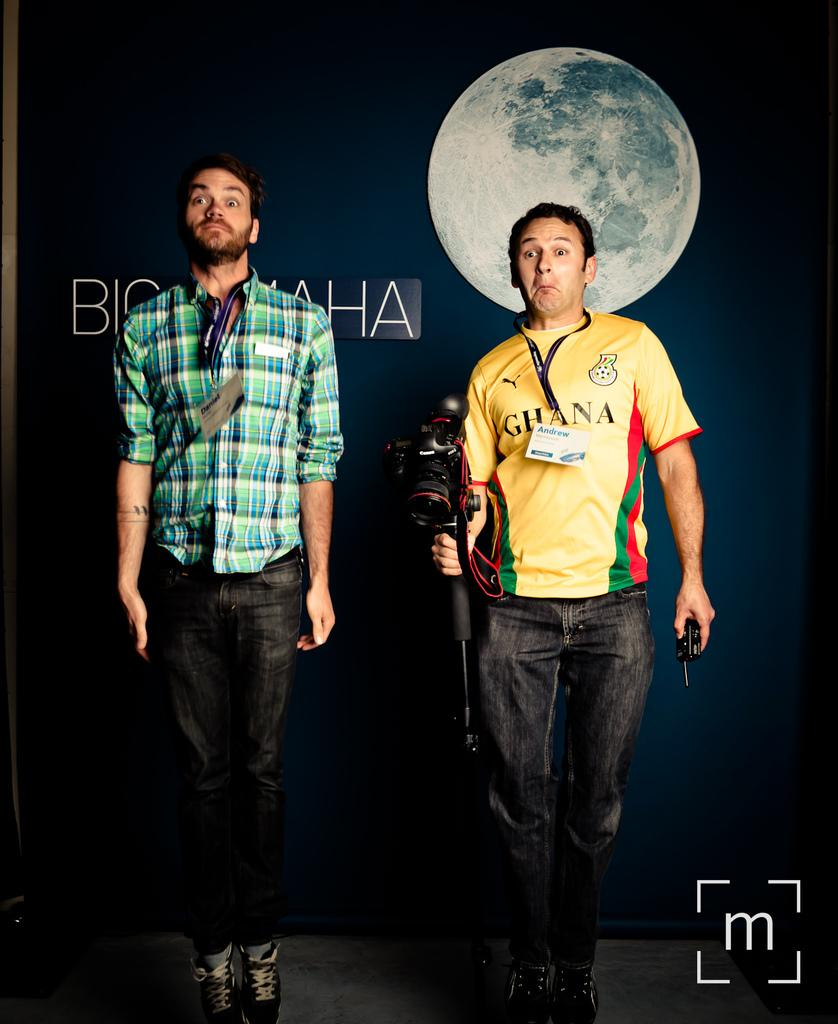Provide a one-sentence caption for the provided image. Man wearing a yellow Ghana shirt holding a camera. 